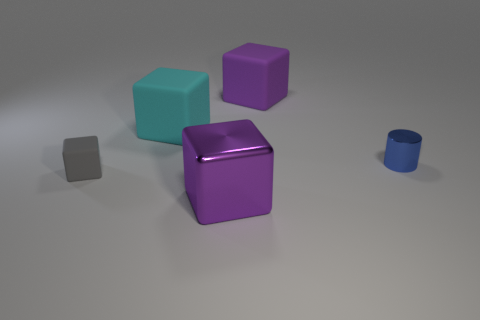Does the large block that is behind the big cyan rubber block have the same color as the big object in front of the tiny blue thing?
Offer a terse response. Yes. There is a thing that is both in front of the tiny blue shiny cylinder and right of the gray object; what color is it?
Give a very brief answer. Purple. Do the blue cylinder and the small gray cube have the same material?
Provide a short and direct response. No. What number of small things are red matte cylinders or metal blocks?
Your answer should be very brief. 0. Is there anything else that is the same shape as the gray thing?
Provide a short and direct response. Yes. Is there any other thing that is the same size as the cyan block?
Your response must be concise. Yes. What color is the small object that is made of the same material as the big cyan block?
Ensure brevity in your answer.  Gray. There is a metal object in front of the tiny gray rubber object; what color is it?
Your answer should be compact. Purple. How many metal blocks are the same color as the tiny matte object?
Give a very brief answer. 0. Are there fewer purple metal things to the left of the cyan block than blue metal objects behind the tiny gray matte cube?
Give a very brief answer. Yes. 